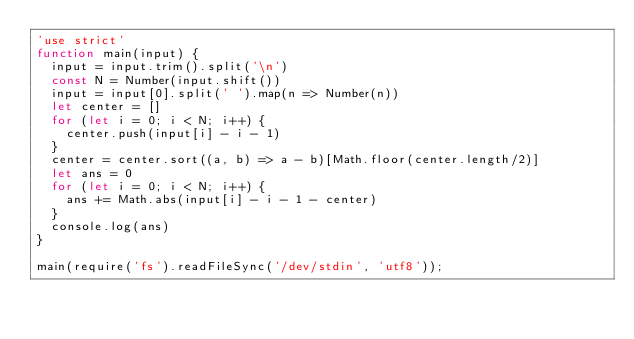Convert code to text. <code><loc_0><loc_0><loc_500><loc_500><_JavaScript_>'use strict'
function main(input) {
  input = input.trim().split('\n')
  const N = Number(input.shift())
  input = input[0].split(' ').map(n => Number(n))
  let center = []
  for (let i = 0; i < N; i++) {
    center.push(input[i] - i - 1)
  }
  center = center.sort((a, b) => a - b)[Math.floor(center.length/2)]
  let ans = 0
  for (let i = 0; i < N; i++) {
    ans += Math.abs(input[i] - i - 1 - center)
  }
  console.log(ans)
}

main(require('fs').readFileSync('/dev/stdin', 'utf8'));
</code> 